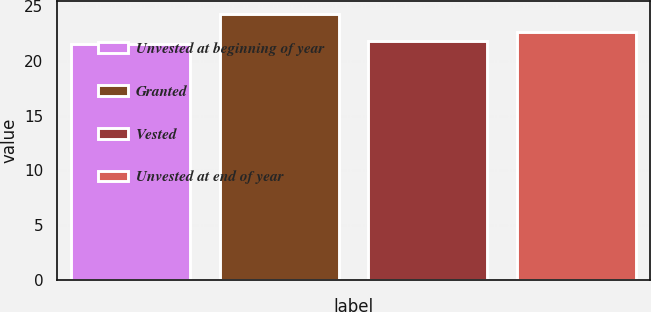Convert chart. <chart><loc_0><loc_0><loc_500><loc_500><bar_chart><fcel>Unvested at beginning of year<fcel>Granted<fcel>Vested<fcel>Unvested at end of year<nl><fcel>21.53<fcel>24.31<fcel>21.86<fcel>22.69<nl></chart> 